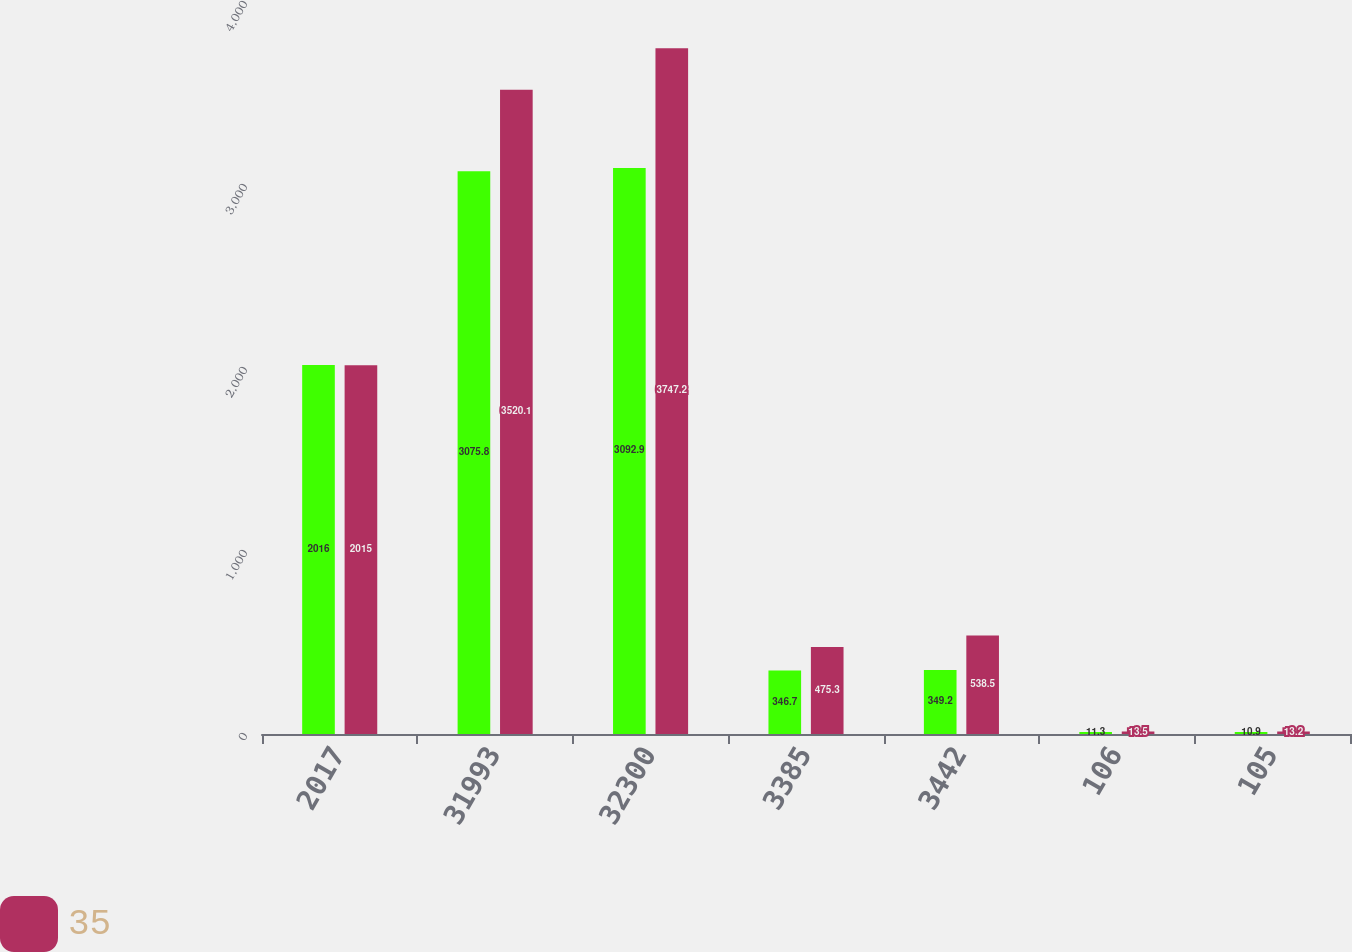Convert chart. <chart><loc_0><loc_0><loc_500><loc_500><stacked_bar_chart><ecel><fcel>2017<fcel>31993<fcel>32300<fcel>3385<fcel>3442<fcel>106<fcel>105<nl><fcel>nan<fcel>2016<fcel>3075.8<fcel>3092.9<fcel>346.7<fcel>349.2<fcel>11.3<fcel>10.9<nl><fcel>35<fcel>2015<fcel>3520.1<fcel>3747.2<fcel>475.3<fcel>538.5<fcel>13.5<fcel>13.2<nl></chart> 